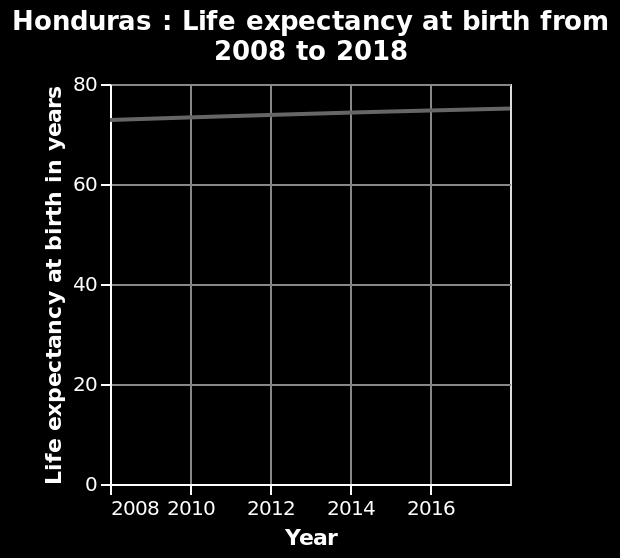<image>
What is the trend in life expectancy age over the years?  The trend in life expectancy age is upward, it is increasing. What is the maximum value on the y-axis of the line chart? The maximum value on the y-axis of the line chart is 80, representing the highest life expectancy at birth in years. 